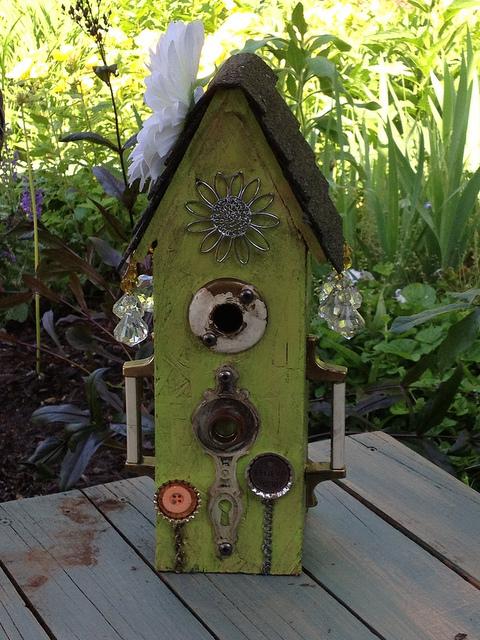How many flowers are there?
Short answer required. 1. What is the green object on the table?
Concise answer only. Birdhouse. Where is the white flower?
Short answer required. On roof. 